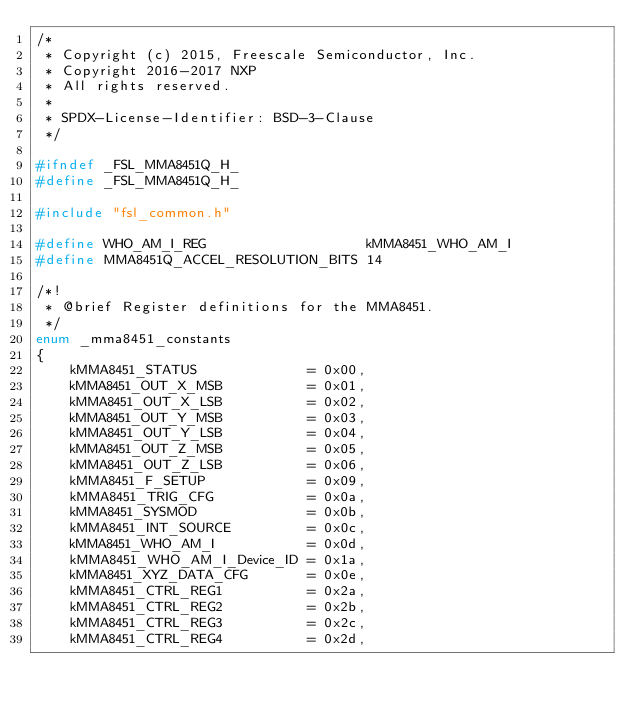<code> <loc_0><loc_0><loc_500><loc_500><_C_>/*
 * Copyright (c) 2015, Freescale Semiconductor, Inc.
 * Copyright 2016-2017 NXP
 * All rights reserved.
 *
 * SPDX-License-Identifier: BSD-3-Clause
 */

#ifndef _FSL_MMA8451Q_H_
#define _FSL_MMA8451Q_H_

#include "fsl_common.h"

#define WHO_AM_I_REG                   kMMA8451_WHO_AM_I
#define MMA8451Q_ACCEL_RESOLUTION_BITS 14

/*!
 * @brief Register definitions for the MMA8451.
 */
enum _mma8451_constants
{
    kMMA8451_STATUS             = 0x00,
    kMMA8451_OUT_X_MSB          = 0x01,
    kMMA8451_OUT_X_LSB          = 0x02,
    kMMA8451_OUT_Y_MSB          = 0x03,
    kMMA8451_OUT_Y_LSB          = 0x04,
    kMMA8451_OUT_Z_MSB          = 0x05,
    kMMA8451_OUT_Z_LSB          = 0x06,
    kMMA8451_F_SETUP            = 0x09,
    kMMA8451_TRIG_CFG           = 0x0a,
    kMMA8451_SYSMOD             = 0x0b,
    kMMA8451_INT_SOURCE         = 0x0c,
    kMMA8451_WHO_AM_I           = 0x0d,
    kMMA8451_WHO_AM_I_Device_ID = 0x1a,
    kMMA8451_XYZ_DATA_CFG       = 0x0e,
    kMMA8451_CTRL_REG1          = 0x2a,
    kMMA8451_CTRL_REG2          = 0x2b,
    kMMA8451_CTRL_REG3          = 0x2c,
    kMMA8451_CTRL_REG4          = 0x2d,</code> 